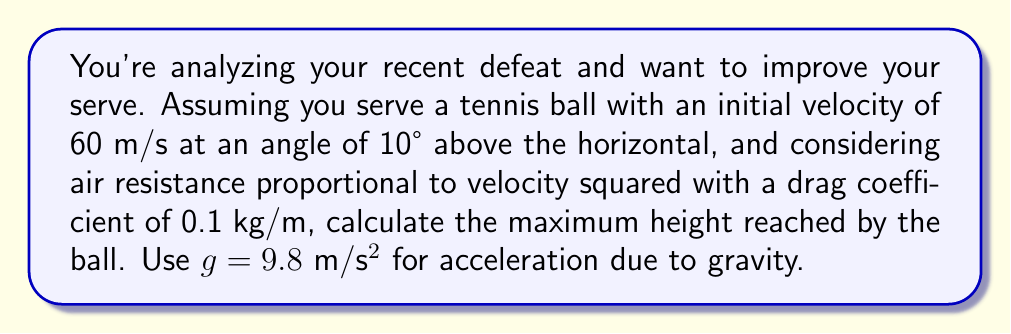Show me your answer to this math problem. To solve this problem, we'll use the equations of motion for a projectile with air resistance. The air resistance force is given by $F_d = -bv^2$, where $b$ is the drag coefficient.

Step 1: Decompose the initial velocity into horizontal and vertical components.
$v_{0x} = v_0 \cos \theta = 60 \cos 10° = 59.1$ m/s
$v_{0y} = v_0 \sin \theta = 60 \sin 10° = 10.4$ m/s

Step 2: Set up the differential equations for motion in x and y directions.
$$\frac{d^2x}{dt^2} = -\frac{b}{m}\sqrt{\left(\frac{dx}{dt}\right)^2 + \left(\frac{dy}{dt}\right)^2}\frac{dx}{dt}$$
$$\frac{d^2y}{dt^2} = -g - \frac{b}{m}\sqrt{\left(\frac{dx}{dt}\right)^2 + \left(\frac{dy}{dt}\right)^2}\frac{dy}{dt}$$

Step 3: These equations are complex and typically require numerical methods to solve. However, we can approximate the maximum height by considering only the vertical motion and neglecting horizontal velocity in the air resistance term.

$$\frac{d^2y}{dt^2} \approx -g - \frac{b}{m}\left(\frac{dy}{dt}\right)^2$$

Step 4: At the maximum height, $\frac{dy}{dt} = 0$. Integrate the equation from the initial condition to this point:

$$\int_{v_{0y}}^0 \frac{dv}{g + \frac{b}{m}v^2} = -\int_0^t dt$$

Step 5: Solve this integral:

$$\frac{1}{\sqrt{g\frac{b}{m}}} \arctan\left(\sqrt{\frac{b}{mg}}v\right)\bigg|_{v_{0y}}^0 = -t$$

$$t = \frac{1}{\sqrt{g\frac{b}{m}}} \arctan\left(\sqrt{\frac{b}{mg}}v_{0y}\right)$$

Step 6: Use this time in the equation for vertical displacement:

$$y = v_{0y}t - \frac{1}{2}gt^2$$

Step 7: Substitute the values:
$m = 1$ kg (assumed), $b = 0.1$ kg/m, $g = 9.8$ m/s², $v_{0y} = 10.4$ m/s

$$t = \frac{1}{\sqrt{9.8 \cdot 0.1}} \arctan\left(\sqrt{\frac{0.1}{9.8}}10.4\right) = 0.331 \text{ s}$$

$$y_{\text{max}} = 10.4 \cdot 0.331 - \frac{1}{2} \cdot 9.8 \cdot 0.331^2 = 2.85 \text{ m}$$
Answer: 2.85 m 